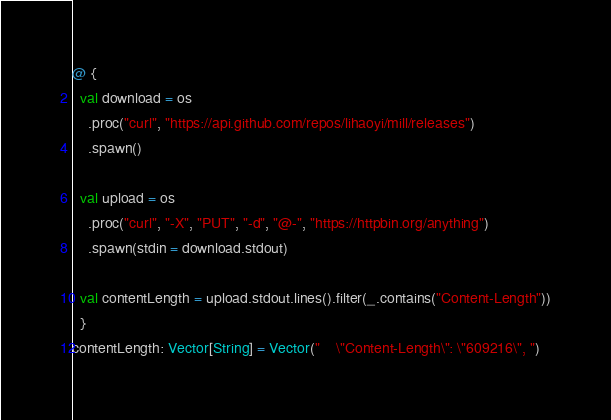Convert code to text. <code><loc_0><loc_0><loc_500><loc_500><_Scala_>@ {
  val download = os
    .proc("curl", "https://api.github.com/repos/lihaoyi/mill/releases")
    .spawn()

  val upload = os
    .proc("curl", "-X", "PUT", "-d", "@-", "https://httpbin.org/anything")
    .spawn(stdin = download.stdout)

  val contentLength = upload.stdout.lines().filter(_.contains("Content-Length"))
  }
contentLength: Vector[String] = Vector("    \"Content-Length\": \"609216\", ")
</code> 